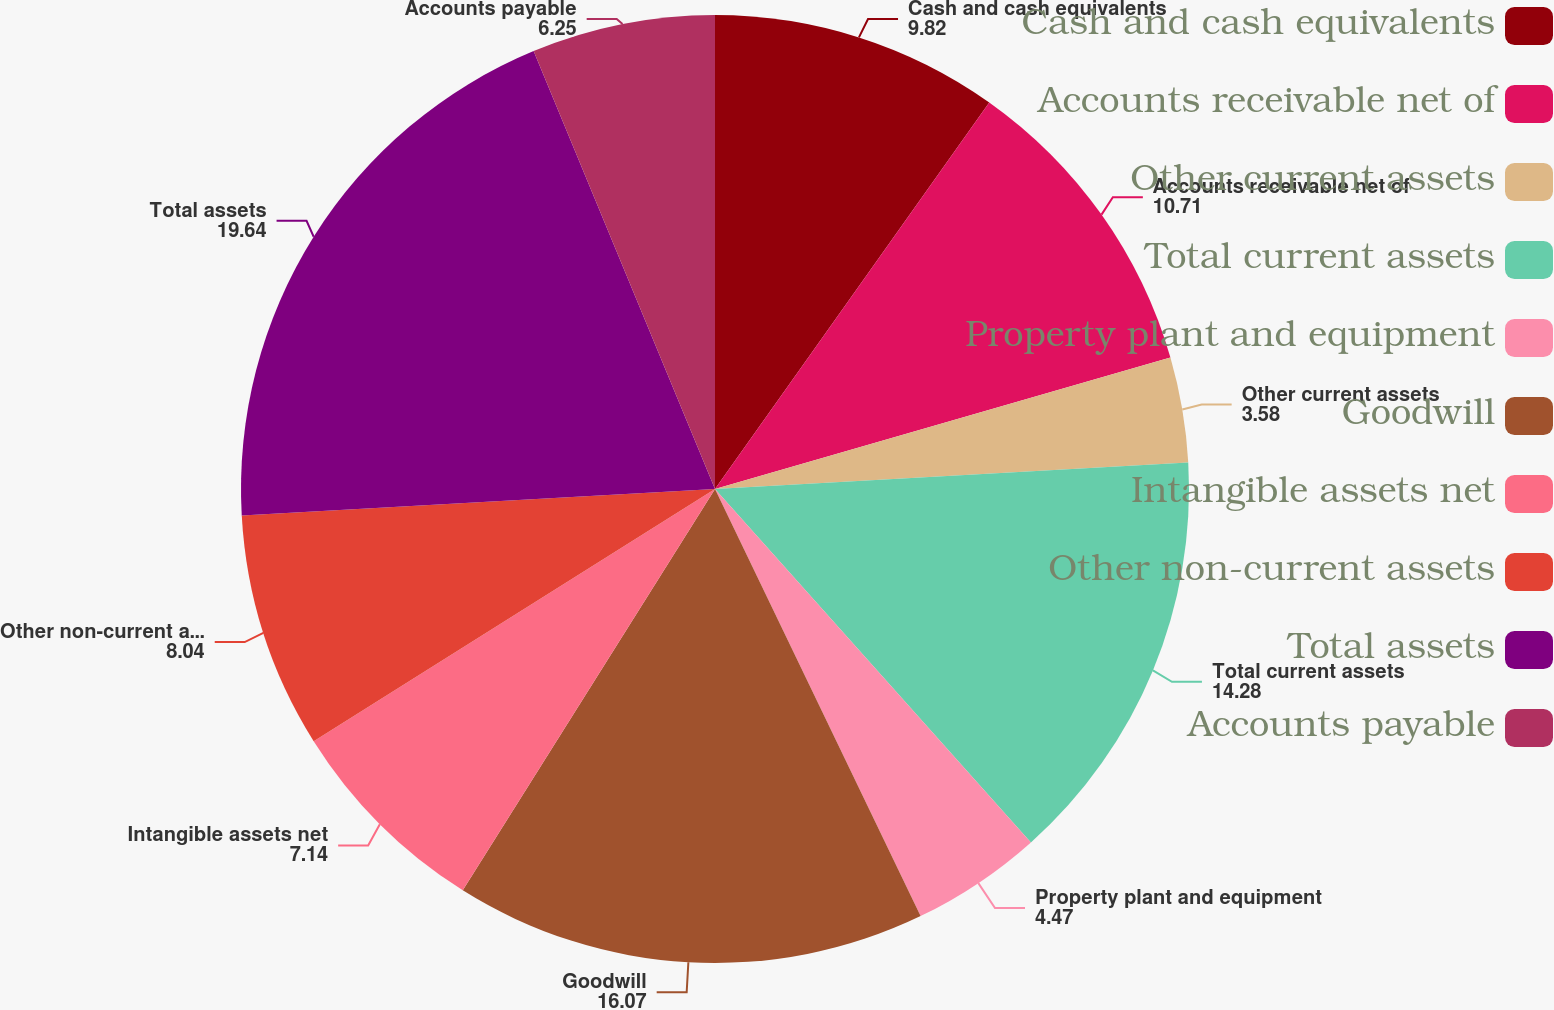Convert chart. <chart><loc_0><loc_0><loc_500><loc_500><pie_chart><fcel>Cash and cash equivalents<fcel>Accounts receivable net of<fcel>Other current assets<fcel>Total current assets<fcel>Property plant and equipment<fcel>Goodwill<fcel>Intangible assets net<fcel>Other non-current assets<fcel>Total assets<fcel>Accounts payable<nl><fcel>9.82%<fcel>10.71%<fcel>3.58%<fcel>14.28%<fcel>4.47%<fcel>16.07%<fcel>7.14%<fcel>8.04%<fcel>19.64%<fcel>6.25%<nl></chart> 